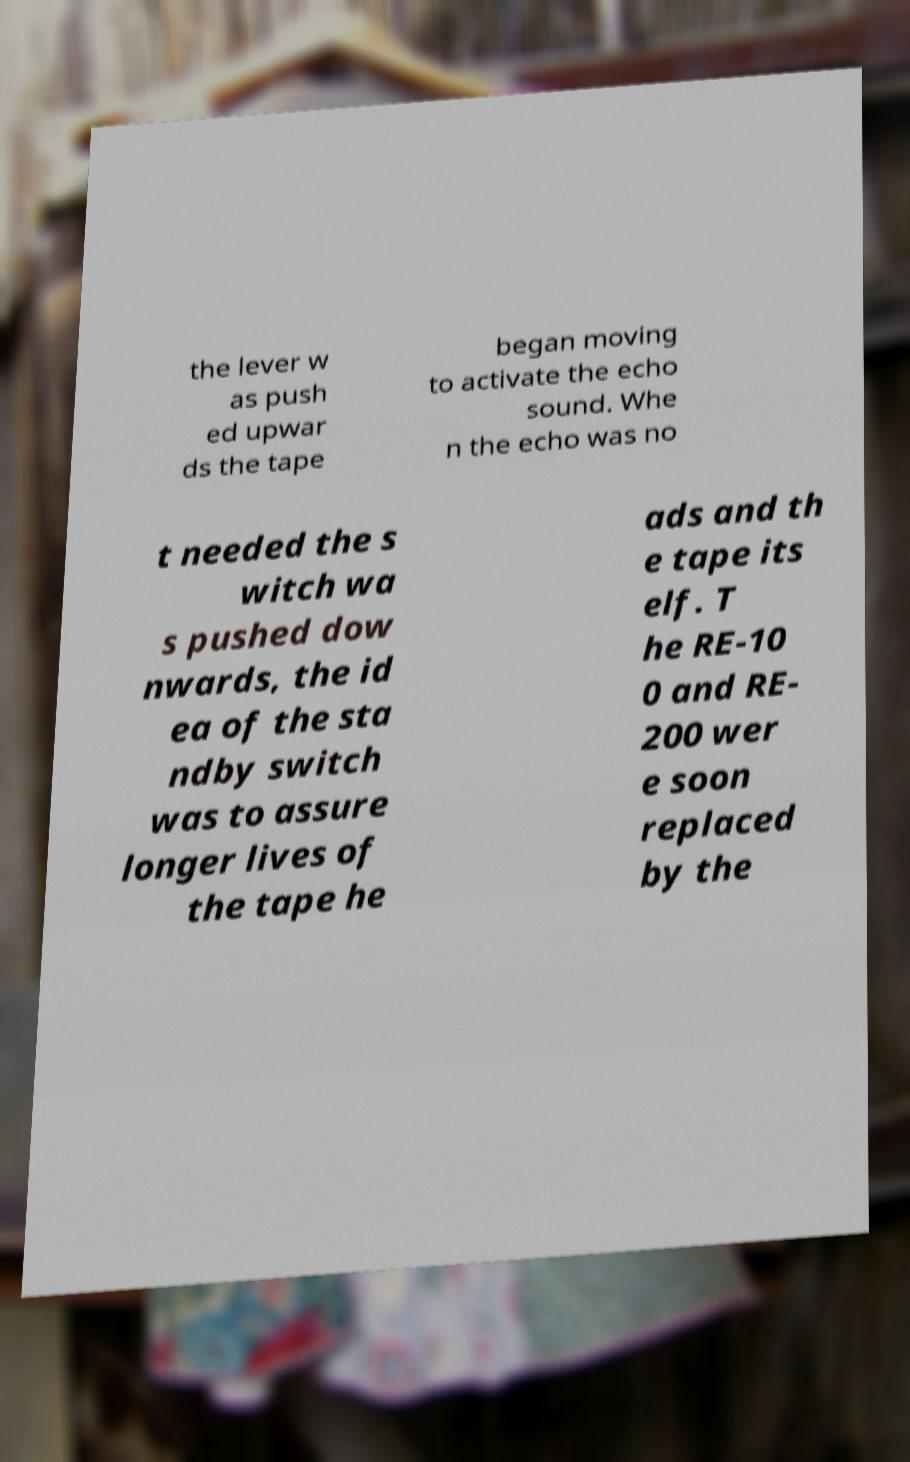Could you assist in decoding the text presented in this image and type it out clearly? the lever w as push ed upwar ds the tape began moving to activate the echo sound. Whe n the echo was no t needed the s witch wa s pushed dow nwards, the id ea of the sta ndby switch was to assure longer lives of the tape he ads and th e tape its elf. T he RE-10 0 and RE- 200 wer e soon replaced by the 